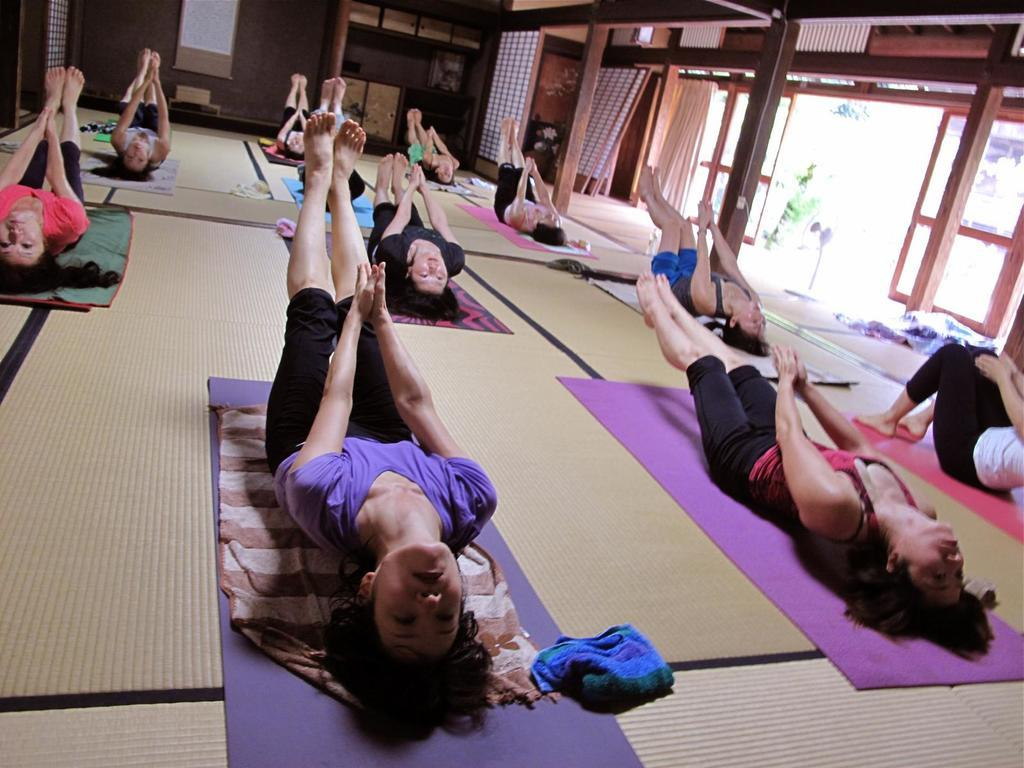What are the women in the image doing? The women in the image are doing exercise. Where are the women located in the image? The women are on the floor. What can be seen in the background of the image? There is a wall, curtains, doors, and windows in the background of the image. What type of grain is being used as a scarf by one of the women in the image? There is no grain or scarf present in the image; the women are simply doing exercise on the floor. 